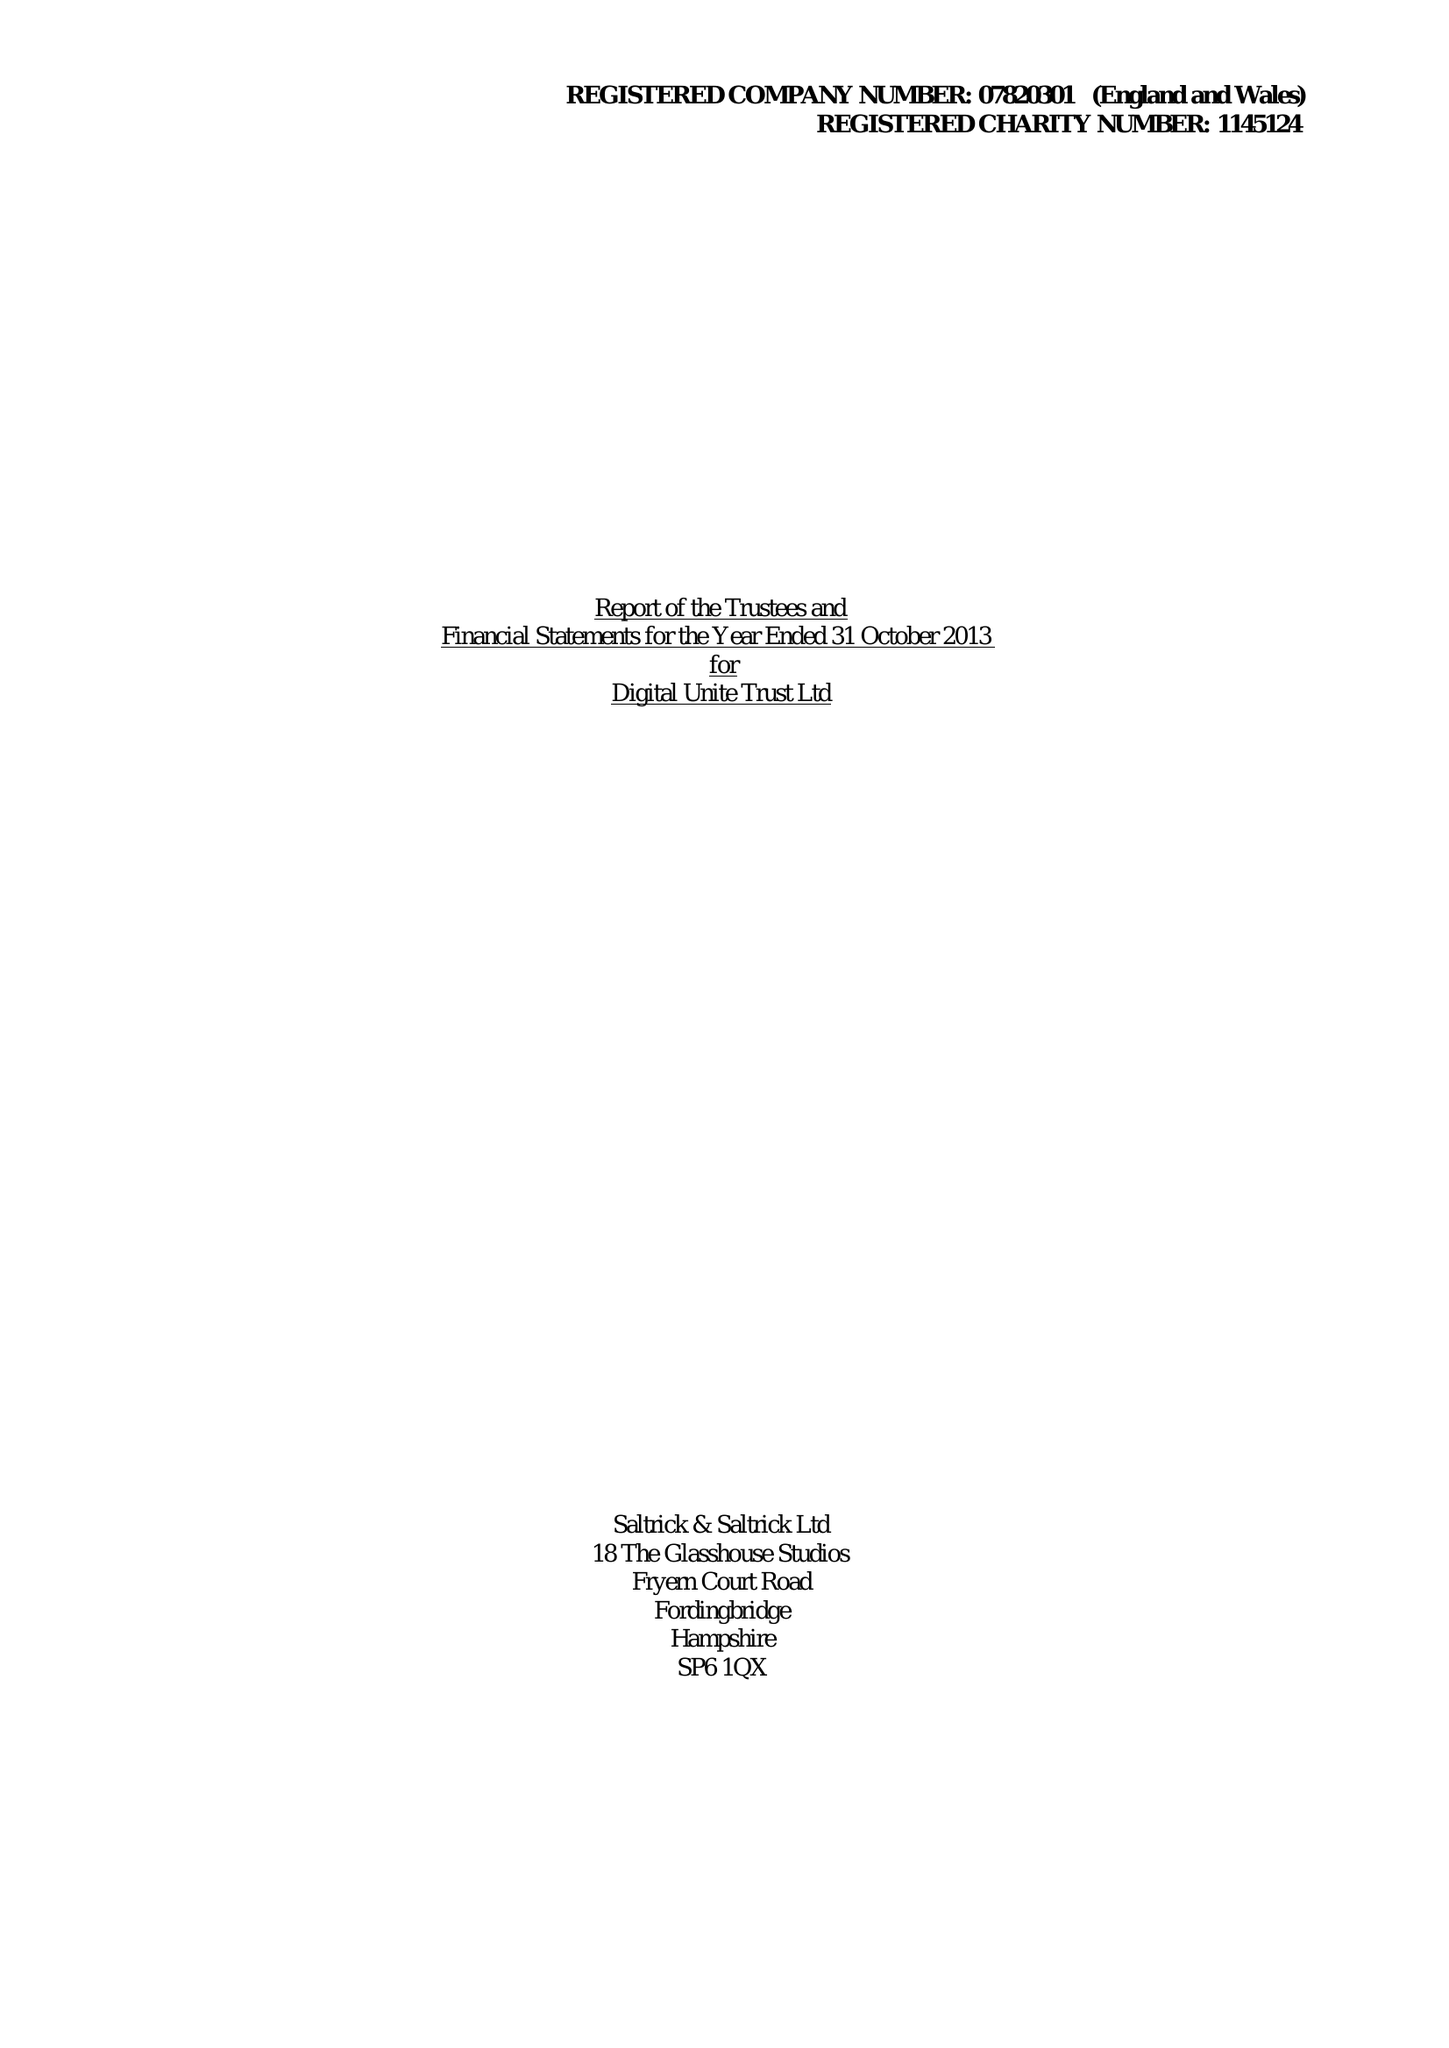What is the value for the income_annually_in_british_pounds?
Answer the question using a single word or phrase. 61533.00 